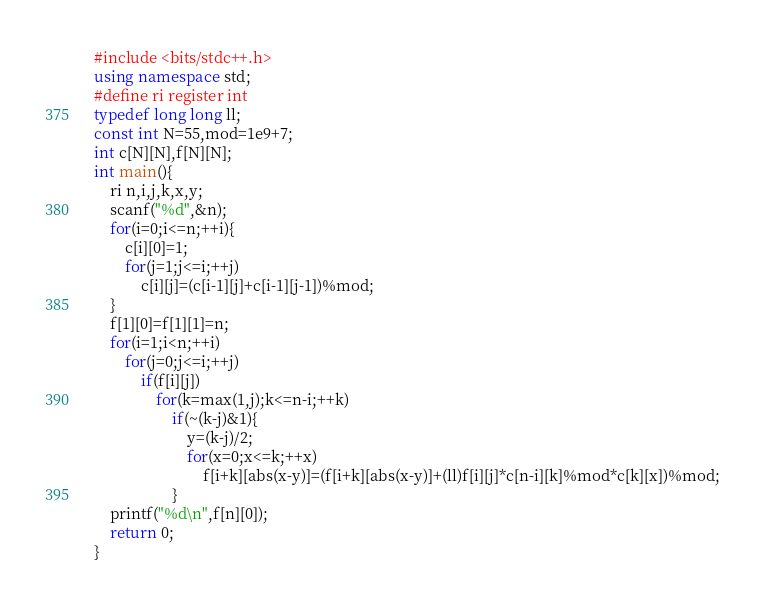<code> <loc_0><loc_0><loc_500><loc_500><_C++_>#include <bits/stdc++.h>
using namespace std;
#define ri register int
typedef long long ll;
const int N=55,mod=1e9+7;
int c[N][N],f[N][N];
int main(){
	ri n,i,j,k,x,y;
	scanf("%d",&n);
	for(i=0;i<=n;++i){
		c[i][0]=1;
		for(j=1;j<=i;++j)
			c[i][j]=(c[i-1][j]+c[i-1][j-1])%mod; 
	}
	f[1][0]=f[1][1]=n;
	for(i=1;i<n;++i)
		for(j=0;j<=i;++j)
			if(f[i][j])
				for(k=max(1,j);k<=n-i;++k)
					if(~(k-j)&1){
						y=(k-j)/2;
						for(x=0;x<=k;++x)
							f[i+k][abs(x-y)]=(f[i+k][abs(x-y)]+(ll)f[i][j]*c[n-i][k]%mod*c[k][x])%mod;
					}
	printf("%d\n",f[n][0]);
	return 0;
}</code> 